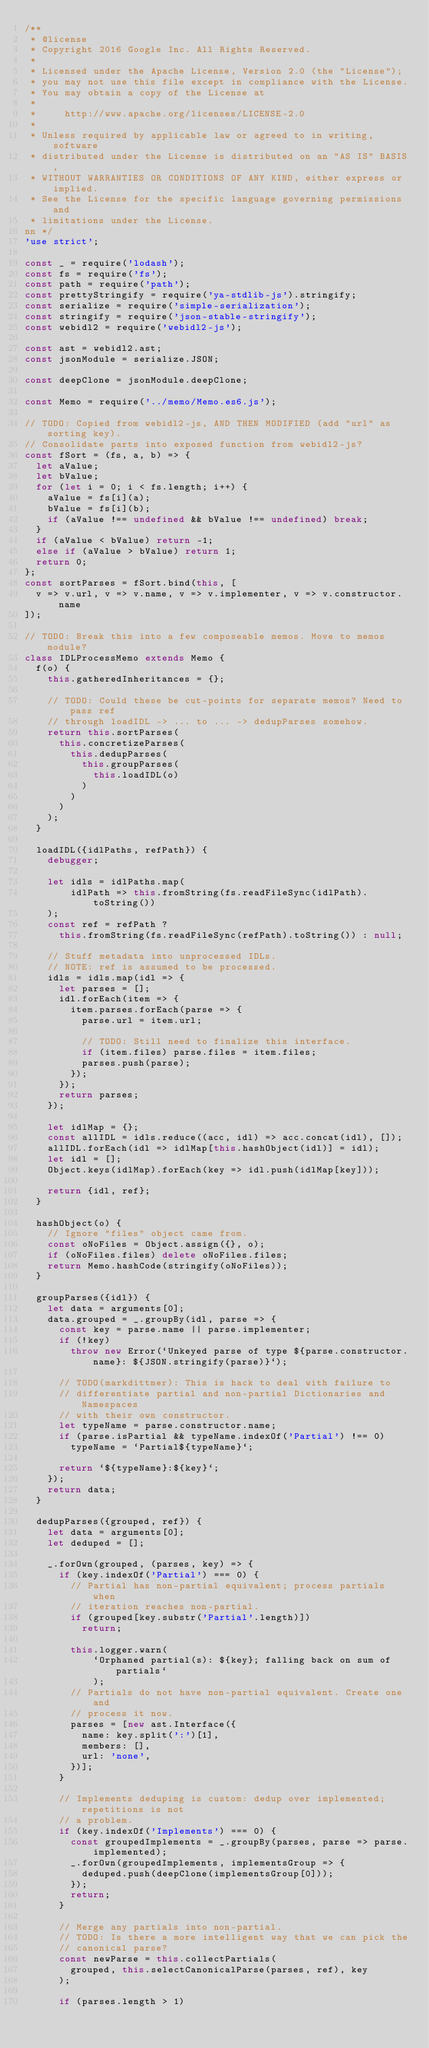Convert code to text. <code><loc_0><loc_0><loc_500><loc_500><_JavaScript_>/**
 * @license
 * Copyright 2016 Google Inc. All Rights Reserved.
 *
 * Licensed under the Apache License, Version 2.0 (the "License");
 * you may not use this file except in compliance with the License.
 * You may obtain a copy of the License at
 *
 *     http://www.apache.org/licenses/LICENSE-2.0
 *
 * Unless required by applicable law or agreed to in writing, software
 * distributed under the License is distributed on an "AS IS" BASIS,
 * WITHOUT WARRANTIES OR CONDITIONS OF ANY KIND, either express or implied.
 * See the License for the specific language governing permissions and
 * limitations under the License.
nn */
'use strict';

const _ = require('lodash');
const fs = require('fs');
const path = require('path');
const prettyStringify = require('ya-stdlib-js').stringify;
const serialize = require('simple-serialization');
const stringify = require('json-stable-stringify');
const webidl2 = require('webidl2-js');

const ast = webidl2.ast;
const jsonModule = serialize.JSON;

const deepClone = jsonModule.deepClone;

const Memo = require('../memo/Memo.es6.js');

// TODO: Copied from webidl2-js, AND THEN MODIFIED (add "url" as sorting key).
// Consolidate parts into exposed function from webidl2-js?
const fSort = (fs, a, b) => {
  let aValue;
  let bValue;
  for (let i = 0; i < fs.length; i++) {
    aValue = fs[i](a);
    bValue = fs[i](b);
    if (aValue !== undefined && bValue !== undefined) break;
  }
  if (aValue < bValue) return -1;
  else if (aValue > bValue) return 1;
  return 0;
};
const sortParses = fSort.bind(this, [
  v => v.url, v => v.name, v => v.implementer, v => v.constructor.name
]);

// TODO: Break this into a few composeable memos. Move to memos module?
class IDLProcessMemo extends Memo {
  f(o) {
    this.gatheredInheritances = {};

    // TODO: Could these be cut-points for separate memos? Need to pass ref
    // through loadIDL -> ... to ... -> dedupParses somehow.
    return this.sortParses(
      this.concretizeParses(
        this.dedupParses(
          this.groupParses(
            this.loadIDL(o)
          )
        )
      )
    );
  }

  loadIDL({idlPaths, refPath}) {
    debugger;

    let idls = idlPaths.map(
        idlPath => this.fromString(fs.readFileSync(idlPath).toString())
    );
    const ref = refPath ?
      this.fromString(fs.readFileSync(refPath).toString()) : null;

    // Stuff metadata into unprocessed IDLs.
    // NOTE: ref is assumed to be processed.
    idls = idls.map(idl => {
      let parses = [];
      idl.forEach(item => {
        item.parses.forEach(parse => {
          parse.url = item.url;

          // TODO: Still need to finalize this interface.
          if (item.files) parse.files = item.files;
          parses.push(parse);
        });
      });
      return parses;
    });

    let idlMap = {};
    const allIDL = idls.reduce((acc, idl) => acc.concat(idl), []);
    allIDL.forEach(idl => idlMap[this.hashObject(idl)] = idl);
    let idl = [];
    Object.keys(idlMap).forEach(key => idl.push(idlMap[key]));

    return {idl, ref};
  }

  hashObject(o) {
    // Ignore "files" object came from.
    const oNoFiles = Object.assign({}, o);
    if (oNoFiles.files) delete oNoFiles.files;
    return Memo.hashCode(stringify(oNoFiles));
  }

  groupParses({idl}) {
    let data = arguments[0];
    data.grouped = _.groupBy(idl, parse => {
      const key = parse.name || parse.implementer;
      if (!key)
        throw new Error(`Unkeyed parse of type ${parse.constructor.name}: ${JSON.stringify(parse)}`);

      // TODO(markdittmer): This is hack to deal with failure to
      // differentiate partial and non-partial Dictionaries and Namespaces
      // with their own constructor.
      let typeName = parse.constructor.name;
      if (parse.isPartial && typeName.indexOf('Partial') !== 0)
        typeName = `Partial${typeName}`;

      return `${typeName}:${key}`;
    });
    return data;
  }

  dedupParses({grouped, ref}) {
    let data = arguments[0];
    let deduped = [];

    _.forOwn(grouped, (parses, key) => {
      if (key.indexOf('Partial') === 0) {
        // Partial has non-partial equivalent; process partials when
        // iteration reaches non-partial.
        if (grouped[key.substr('Partial'.length)])
          return;

        this.logger.warn(
            `Orphaned partial(s): ${key}; falling back on sum of partials`
            );
        // Partials do not have non-partial equivalent. Create one and
        // process it now.
        parses = [new ast.Interface({
          name: key.split(':')[1],
          members: [],
          url: 'none',
        })];
      }

      // Implements deduping is custom: dedup over implemented; repetitions is not
      // a problem.
      if (key.indexOf('Implements') === 0) {
        const groupedImplements = _.groupBy(parses, parse => parse.implemented);
        _.forOwn(groupedImplements, implementsGroup => {
          deduped.push(deepClone(implementsGroup[0]));
        });
        return;
      }

      // Merge any partials into non-partial.
      // TODO: Is there a more intelligent way that we can pick the
      // canonical parse?
      const newParse = this.collectPartials(
        grouped, this.selectCanonicalParse(parses, ref), key
      );

      if (parses.length > 1)</code> 